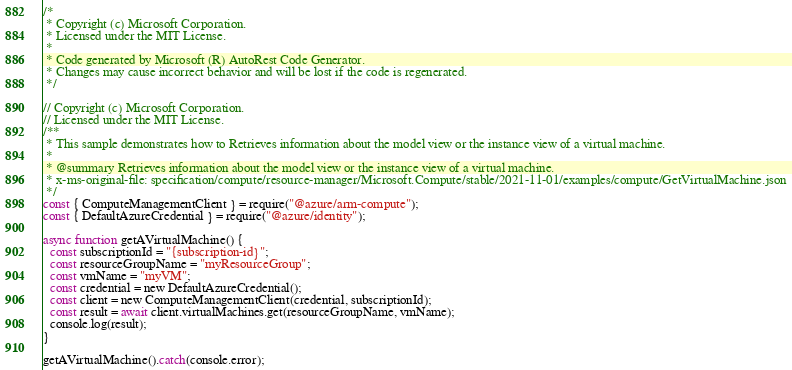<code> <loc_0><loc_0><loc_500><loc_500><_JavaScript_>/*
 * Copyright (c) Microsoft Corporation.
 * Licensed under the MIT License.
 *
 * Code generated by Microsoft (R) AutoRest Code Generator.
 * Changes may cause incorrect behavior and will be lost if the code is regenerated.
 */

// Copyright (c) Microsoft Corporation.
// Licensed under the MIT License.
/**
 * This sample demonstrates how to Retrieves information about the model view or the instance view of a virtual machine.
 *
 * @summary Retrieves information about the model view or the instance view of a virtual machine.
 * x-ms-original-file: specification/compute/resource-manager/Microsoft.Compute/stable/2021-11-01/examples/compute/GetVirtualMachine.json
 */
const { ComputeManagementClient } = require("@azure/arm-compute");
const { DefaultAzureCredential } = require("@azure/identity");

async function getAVirtualMachine() {
  const subscriptionId = "{subscription-id}";
  const resourceGroupName = "myResourceGroup";
  const vmName = "myVM";
  const credential = new DefaultAzureCredential();
  const client = new ComputeManagementClient(credential, subscriptionId);
  const result = await client.virtualMachines.get(resourceGroupName, vmName);
  console.log(result);
}

getAVirtualMachine().catch(console.error);
</code> 